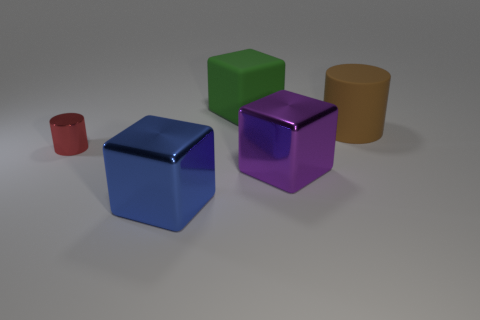What is the color of the large rubber object that is behind the large brown thing?
Provide a succinct answer. Green. Do the small object and the matte cylinder have the same color?
Give a very brief answer. No. How many big objects are right of the big cube that is behind the shiny object that is to the left of the large blue thing?
Ensure brevity in your answer.  2. How big is the green rubber cube?
Your answer should be compact. Large. There is a brown thing that is the same size as the purple shiny thing; what is its material?
Offer a terse response. Rubber. What number of metal things are behind the big blue metal object?
Your answer should be compact. 2. Do the big cube that is to the left of the green matte thing and the cylinder that is left of the purple cube have the same material?
Provide a succinct answer. Yes. What is the shape of the large shiny thing that is to the right of the large thing that is on the left side of the block that is behind the purple metal block?
Give a very brief answer. Cube. The big green rubber object has what shape?
Provide a succinct answer. Cube. What is the shape of the blue thing that is the same size as the green rubber thing?
Your answer should be compact. Cube. 